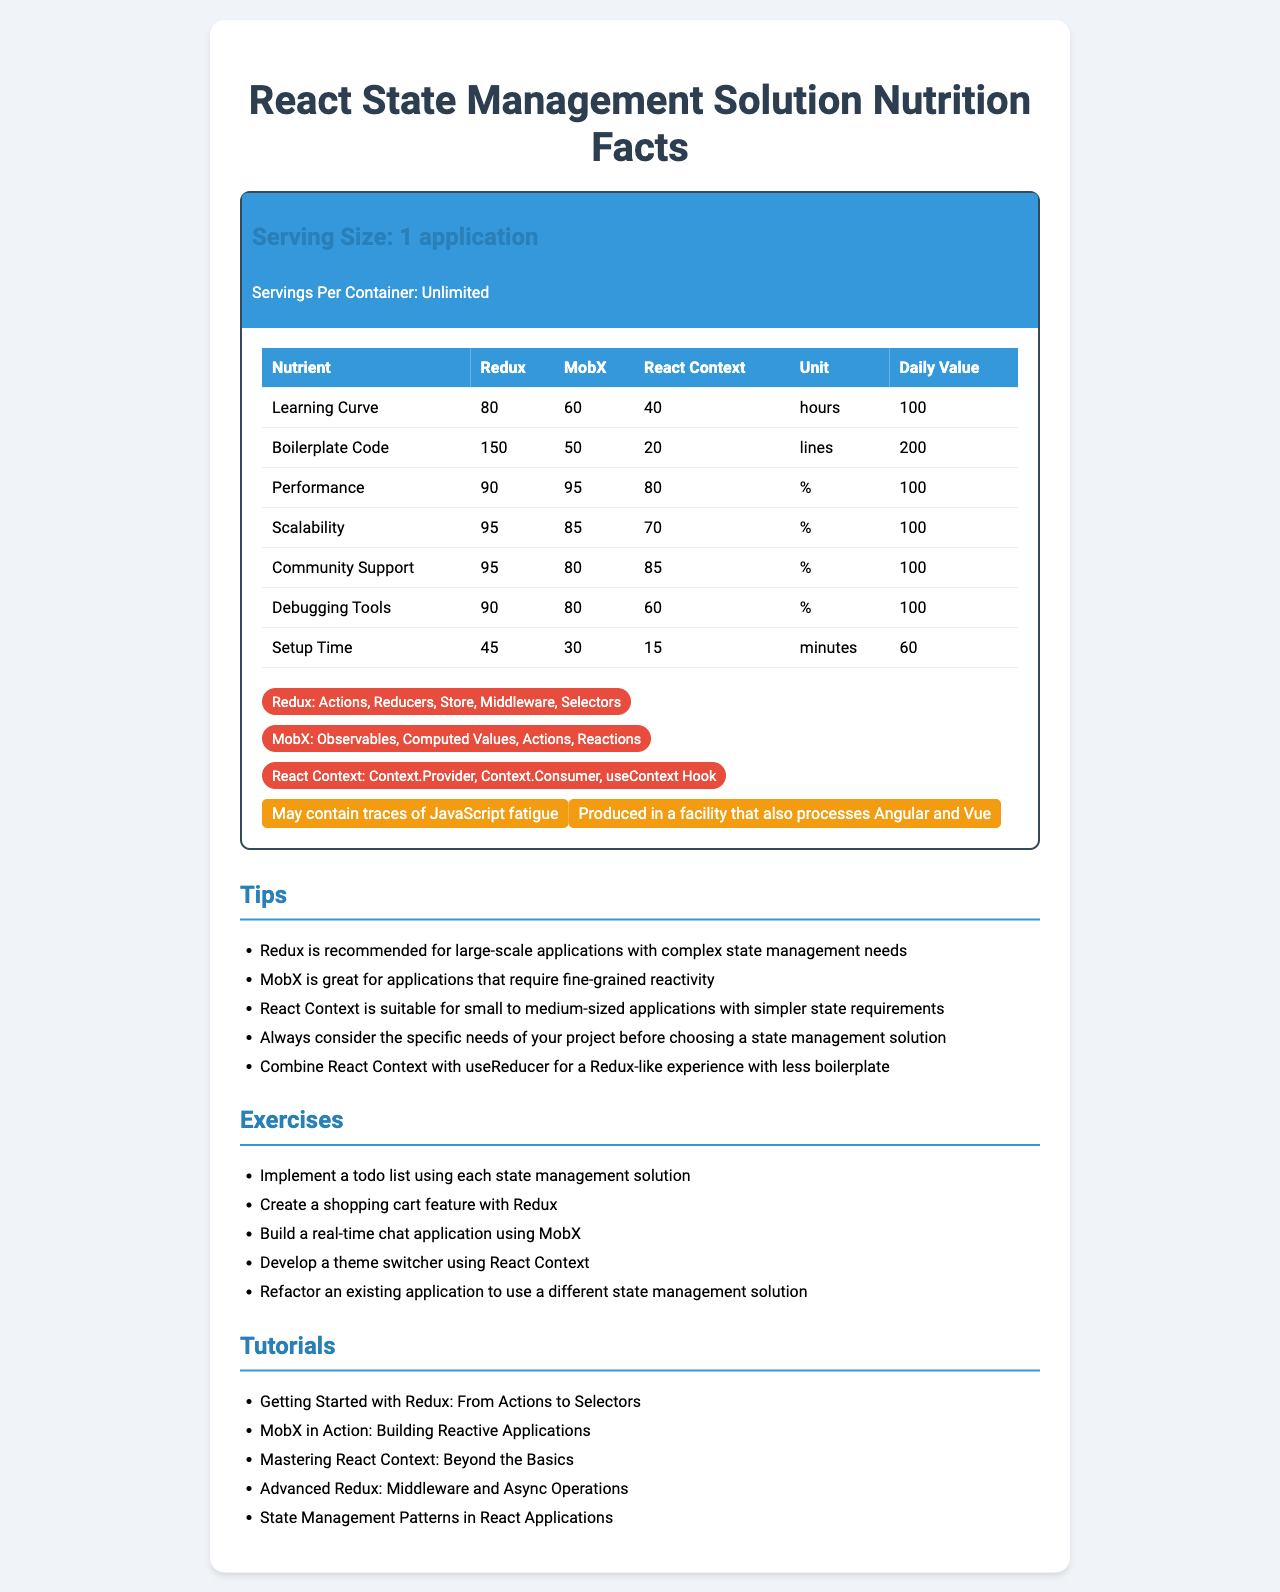what is the serving size of the React State Management Solution? The serving size is stated as "1 application" at the top of the document.
Answer: 1 application how many servings per container are provided? The document states "Servings Per Container: Unlimited."
Answer: Unlimited which state management solution has the highest learning curve in hours? According to the document, Redux has a learning curve of 80 hours, which is higher compared to MobX (60 hours) and React Context (40 hours).
Answer: Redux how much boilerplate code does MobX require? The document lists MobX as requiring 50 lines of boilerplate code.
Answer: 50 lines what is the performance percentage for React Context? The document shows a performance of 80% for React Context.
Answer: 80% which state management solution is recommended for large-scale applications with complex state management needs? One of the tips states that Redux is recommended for large-scale applications with complex state management needs.
Answer: Redux what are the main ingredients for React Context? The document lists the components of React Context as Context.Provider, Context.Consumer, and the useContext Hook.
Answer: Context.Provider, Context.Consumer, useContext Hook which state management solution has the best scalability? The document states that Redux has a scalability of 95%, which is higher than MobX (85%) and React Context (70%).
Answer: Redux between Redux and MobX, which one has better community support? According to the document, Redux has community support of 95%, compared to MobX's 80%.
Answer: Redux what are the setup times for each state management solution? The document lists the setup times as 45 minutes for Redux, 30 minutes for MobX, and 15 minutes for React Context.
Answer: Redux: 45 minutes, MobX: 30 minutes, React Context: 15 minutes what is the daily value for boilerplate code? The document states that the daily value for boilerplate code is 200 lines.
Answer: 200 lines which state management solution provides the most comprehensive debugging tools according to the document? The document indicates that Redux has a debugging tool score of 90%, which is higher than MobX (80%) and React Context (60%).
Answer: Redux how many ingredients (components) does MobX have? MobX includes Observables, Computed Values, Actions, and Reactions.
Answer: 4 based on the tips provided, which state management solution is best for an application with fine-grained reactivity requirements? The tips suggest that MobX is great for applications that require fine-grained reactivity.
Answer: MobX what allergen warnings are listed for the React State Management Solution? The allergen section lists these two warnings.
Answer: May contain traces of JavaScript fatigue and produced in a facility that also processes Angular and Vue which exercise involves building a real-time chat application? The document lists this exercise as one for MobX.
Answer: Build a real-time chat application using MobX among all the nutrients, which one has the highest daily value percentage? They all have a daily value of 100% listed in the document.
Answer: All listed nutrients which nutrient requires the least amount of time for React Context? For React Context, Setup Time requires 15 minutes, which is less than the Learning Curve (40 hours).
Answer: Setup Time what tutorial would you start with if you wanted to learn about middleware and async operations in Redux? A. Getting Started with Redux: From Actions to Selectors B. MobX in Action: Building Reactive Applications C. Mastering React Context: Beyond the Basics D. Advanced Redux: Middleware and Async Operations The document lists "Advanced Redux: Middleware and Async Operations" as a tutorial specifically covering middleware and async operations in Redux.
Answer: D. Advanced Redux: Middleware and Async Operations which solution would you choose for a small to medium-sized application with simpler state requirements? A. Redux B. MobX C. React Context The tips recommend React Context for small to medium-sized applications with simpler state requirements.
Answer: C. React Context is MobX's performance higher than Redux's according to the document? The document lists MobX's performance at 95%, which is slightly higher than Redux's performance at 90%.
Answer: Yes summarize the main purpose of this document This summary encapsulates the overall information presented on the React State Management Nutrition Facts Label to give a clear understanding of its contents and intent.
Answer: The document provides a detailed comparison of three React state management solutions: Redux, MobX, and React Context. It evaluates them across various criteria such as learning curve, boilerplate code, performance, scalability, community support, debugging tools, and setup time. Additionally, it includes tips for choosing the right solution, exercises for practice, relevant tutorials, key ingredients (components) of each solution, and allergen warnings. which state management solution offers better community support and debugging tools but less fine-grained reactivity? According to the document, Redux has high scores in community support (95%) and debugging tools (90%), but is not noted for fine-grained reactivity, which is a key strength of MobX.
Answer: Redux 